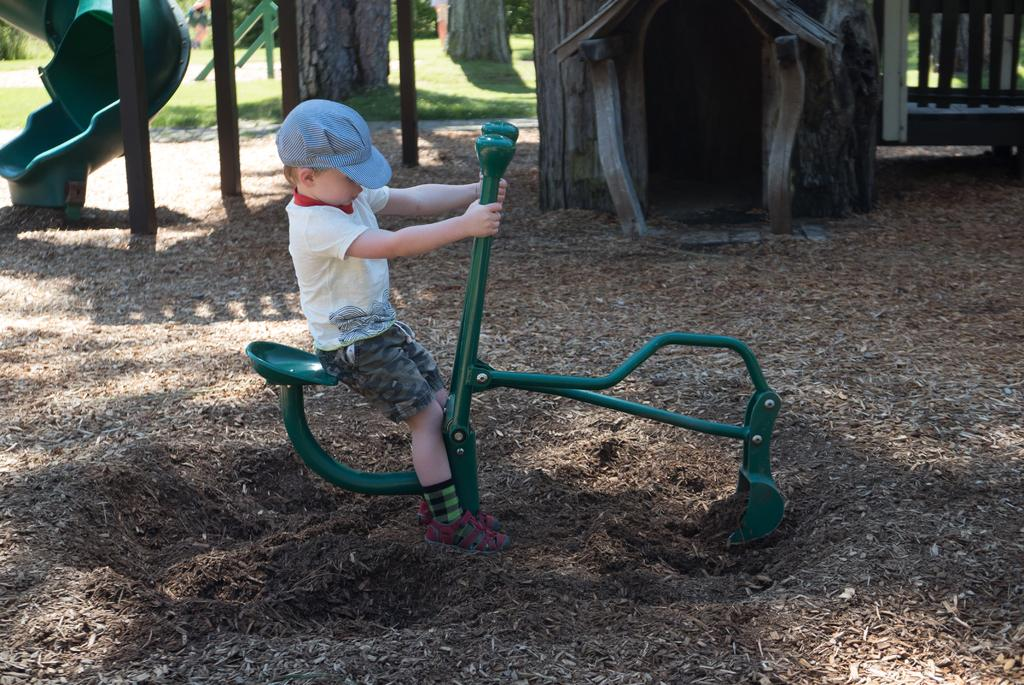What is the person in the image doing? The person is sitting in the image. On what object is the person sitting? The person is sitting on a green object. What structure can be seen in the image? There is a tree-house in the image. What type of terrain is visible in the image? Mud is visible in the image. What type of vegetation is present in the image? There are trees in the image. Can you describe any other objects in the image? There are some unspecified objects in the image. What type of cabbage is being cooked in the image? There is no cabbage or cooking activity present in the image. What date is shown on the calendar in the image? There is no calendar present in the image. 